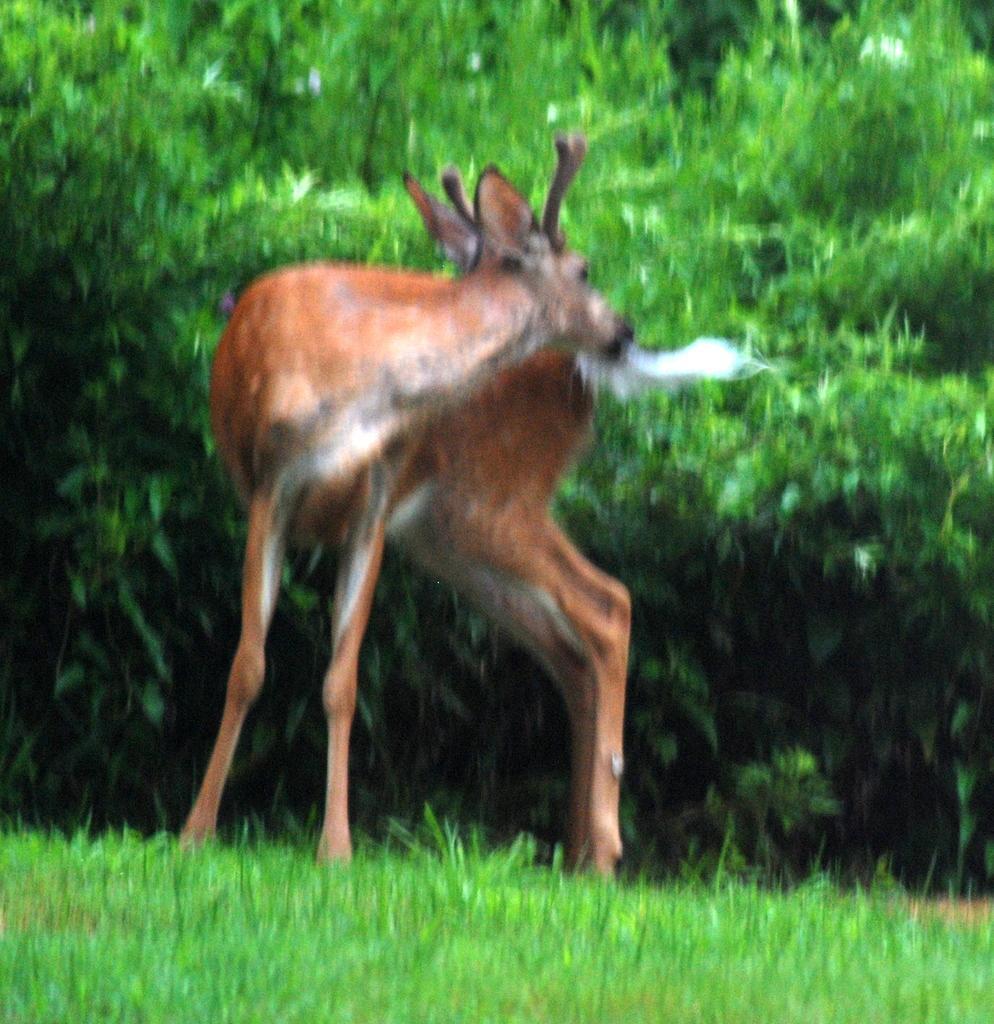Could you give a brief overview of what you see in this image? In this image, I can see a deer standing. This is a grass. In the background, these are the trees, which are green in color. 